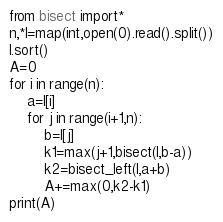Convert code to text. <code><loc_0><loc_0><loc_500><loc_500><_Python_>from bisect import*
n,*l=map(int,open(0).read().split())
l.sort()
A=0
for i in range(n):
    a=l[i]
    for j in range(i+1,n):
        b=l[j]
        k1=max(j+1,bisect(l,b-a))
        k2=bisect_left(l,a+b)
        A+=max(0,k2-k1)
print(A)</code> 